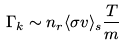<formula> <loc_0><loc_0><loc_500><loc_500>\Gamma _ { k } \sim n _ { r } \langle \sigma v \rangle _ { s } \frac { T } { m }</formula> 